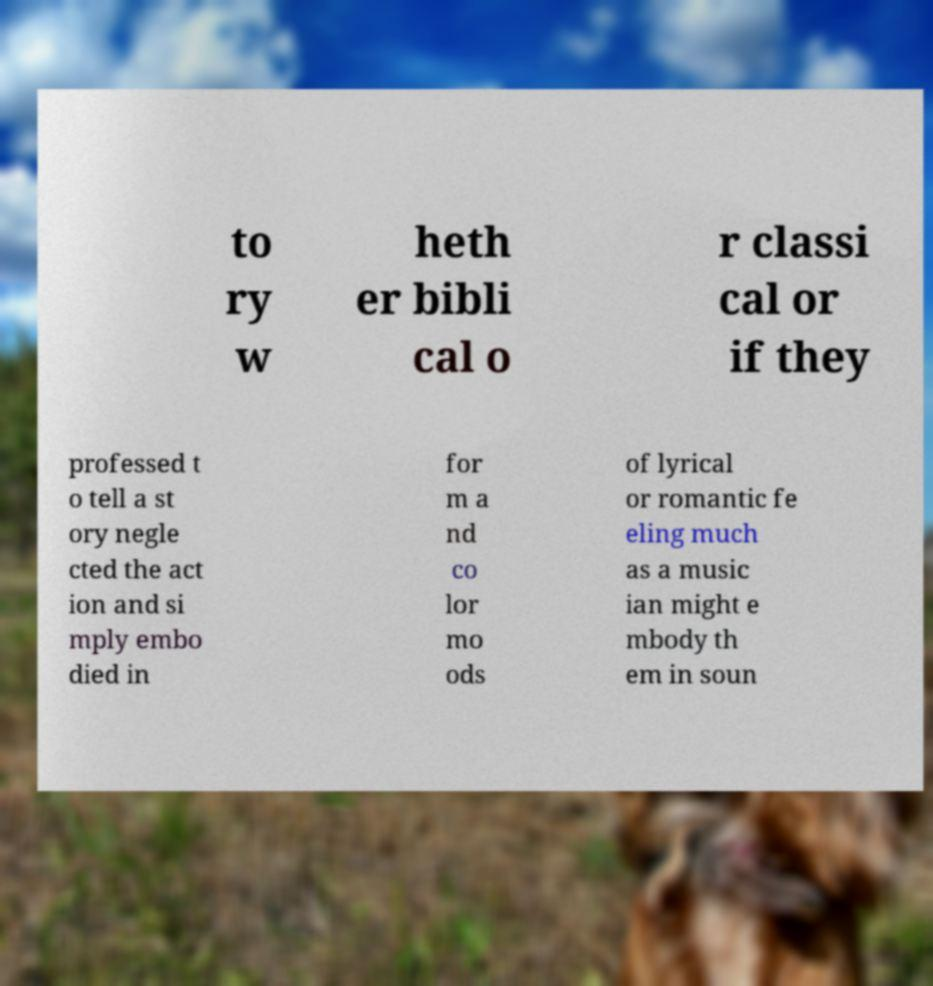Could you assist in decoding the text presented in this image and type it out clearly? to ry w heth er bibli cal o r classi cal or if they professed t o tell a st ory negle cted the act ion and si mply embo died in for m a nd co lor mo ods of lyrical or romantic fe eling much as a music ian might e mbody th em in soun 